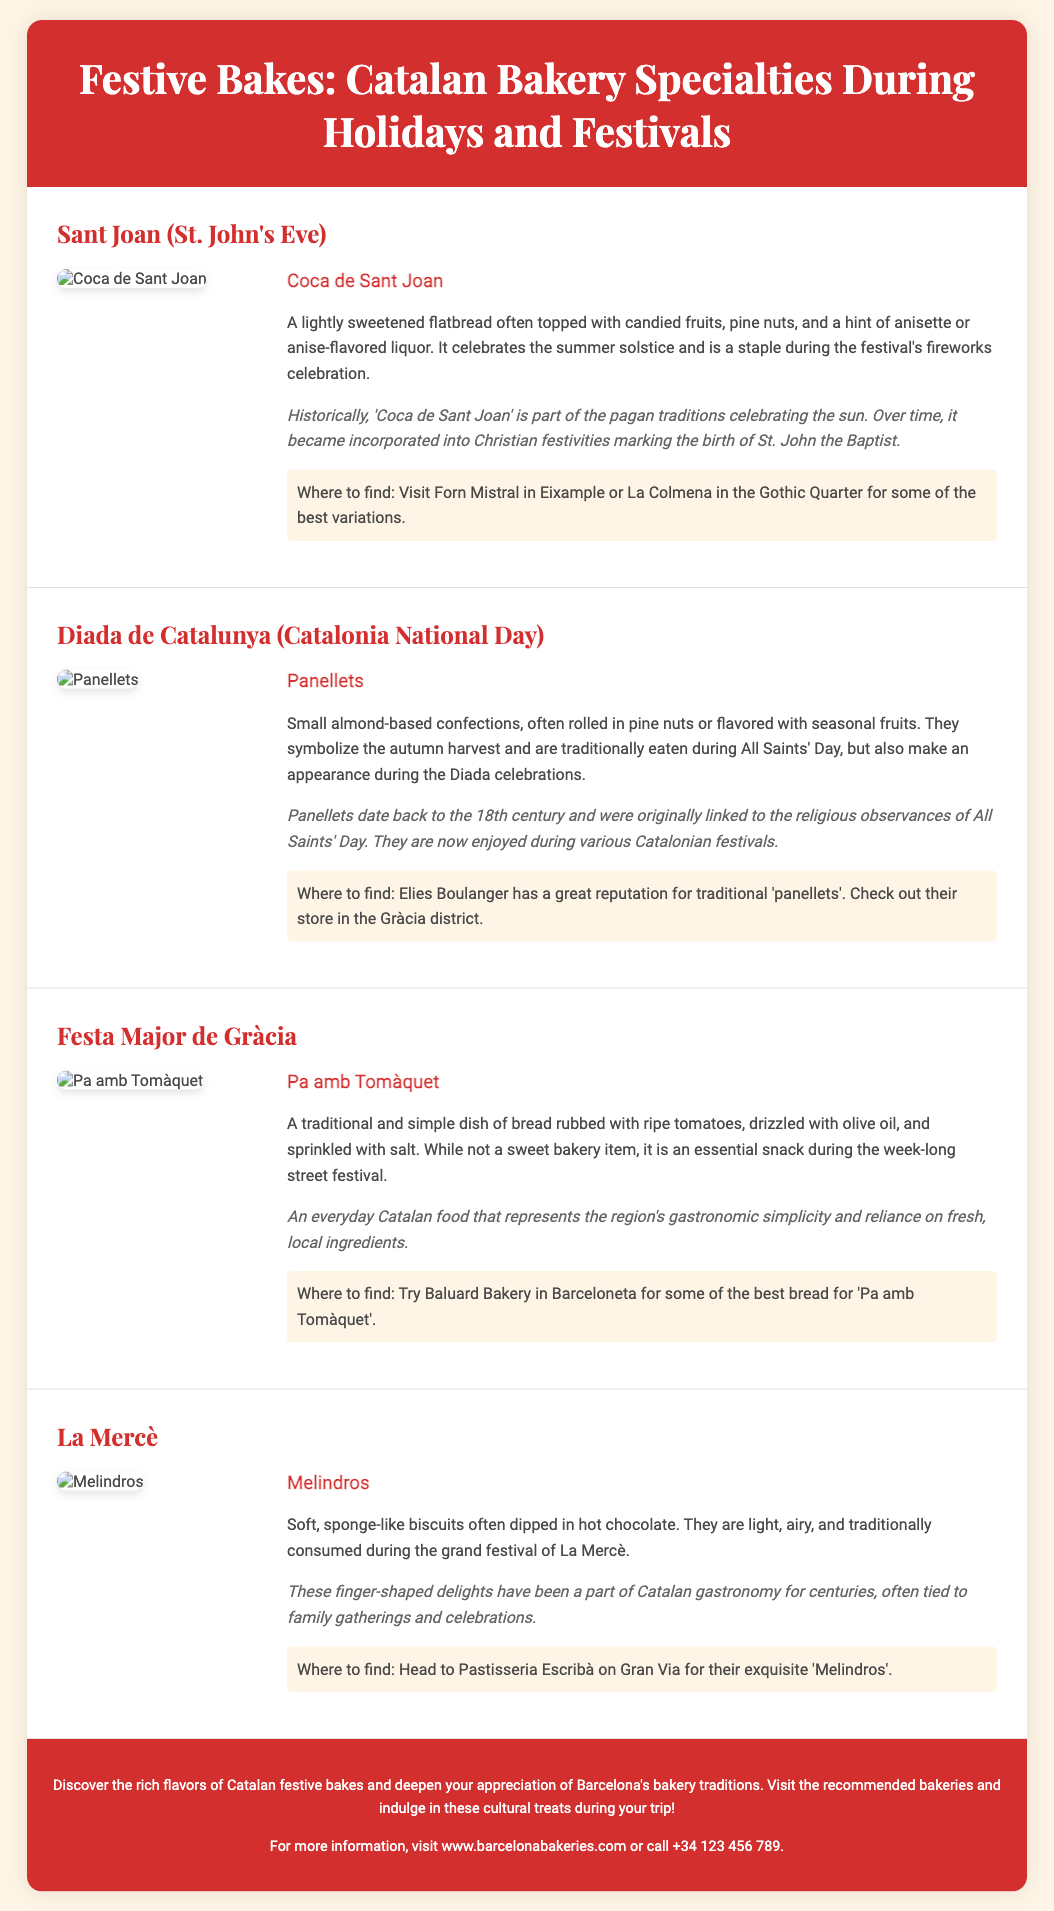What is the title of the flyer? The title of the flyer is prominently displayed at the top and is "Festive Bakes: Catalan Bakery Specialties During Holidays and Festivals."
Answer: Festive Bakes: Catalan Bakery Specialties During Holidays and Festivals What is the name of the sweet flatbread for Sant Joan? The flyer specifies that the sweet flatbread for Sant Joan is called "Coca de Sant Joan."
Answer: Coca de Sant Joan Which bakery is recommended for finding 'Panellets'? The document mentions "Elies Boulanger" as a recommended bakery for finding 'Panellets.'
Answer: Elies Boulanger How many major holidays or festivals are mentioned in the flyer? There are four major holidays or festivals covered in the flyer, each with its own specialty baked item.
Answer: Four What ingredient is Pa amb Tomàquet primarily made of? According to the document, Pa amb Tomàquet is primarily made of bread rubbed with ripe tomatoes.
Answer: Bread and tomatoes What does 'Melindros' traditionally accompany during the festival of La Mercè? The document states that 'Melindros' are traditionally consumed during the festival of La Mercè, often dipped in hot chocolate.
Answer: Hot chocolate Which city is highlighted for finding these festive bakery items? The document specifies that these festive bakery items can be found in "Barcelona."
Answer: Barcelona What historic significance does the Coca de Sant Joan have? The history section mentions that Coca de Sant Joan is part of pagan traditions celebrating the sun, later incorporated into Christian festivities.
Answer: Pagan traditions celebrating the sun Where can one find Coca de Sant Joan in Barcelona? The flyer indicates two places, "Forn Mistral in Eixample" and "La Colmena in the Gothic Quarter," for Coca de Sant Joan.
Answer: Forn Mistral in Eixample and La Colmena in the Gothic Quarter 